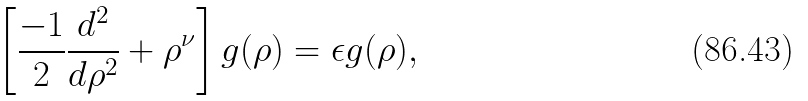Convert formula to latex. <formula><loc_0><loc_0><loc_500><loc_500>\left [ \frac { - 1 } 2 \frac { d ^ { 2 } } { d \rho ^ { 2 } } + \rho ^ { \nu } \right ] g ( \rho ) = \epsilon g ( \rho ) ,</formula> 